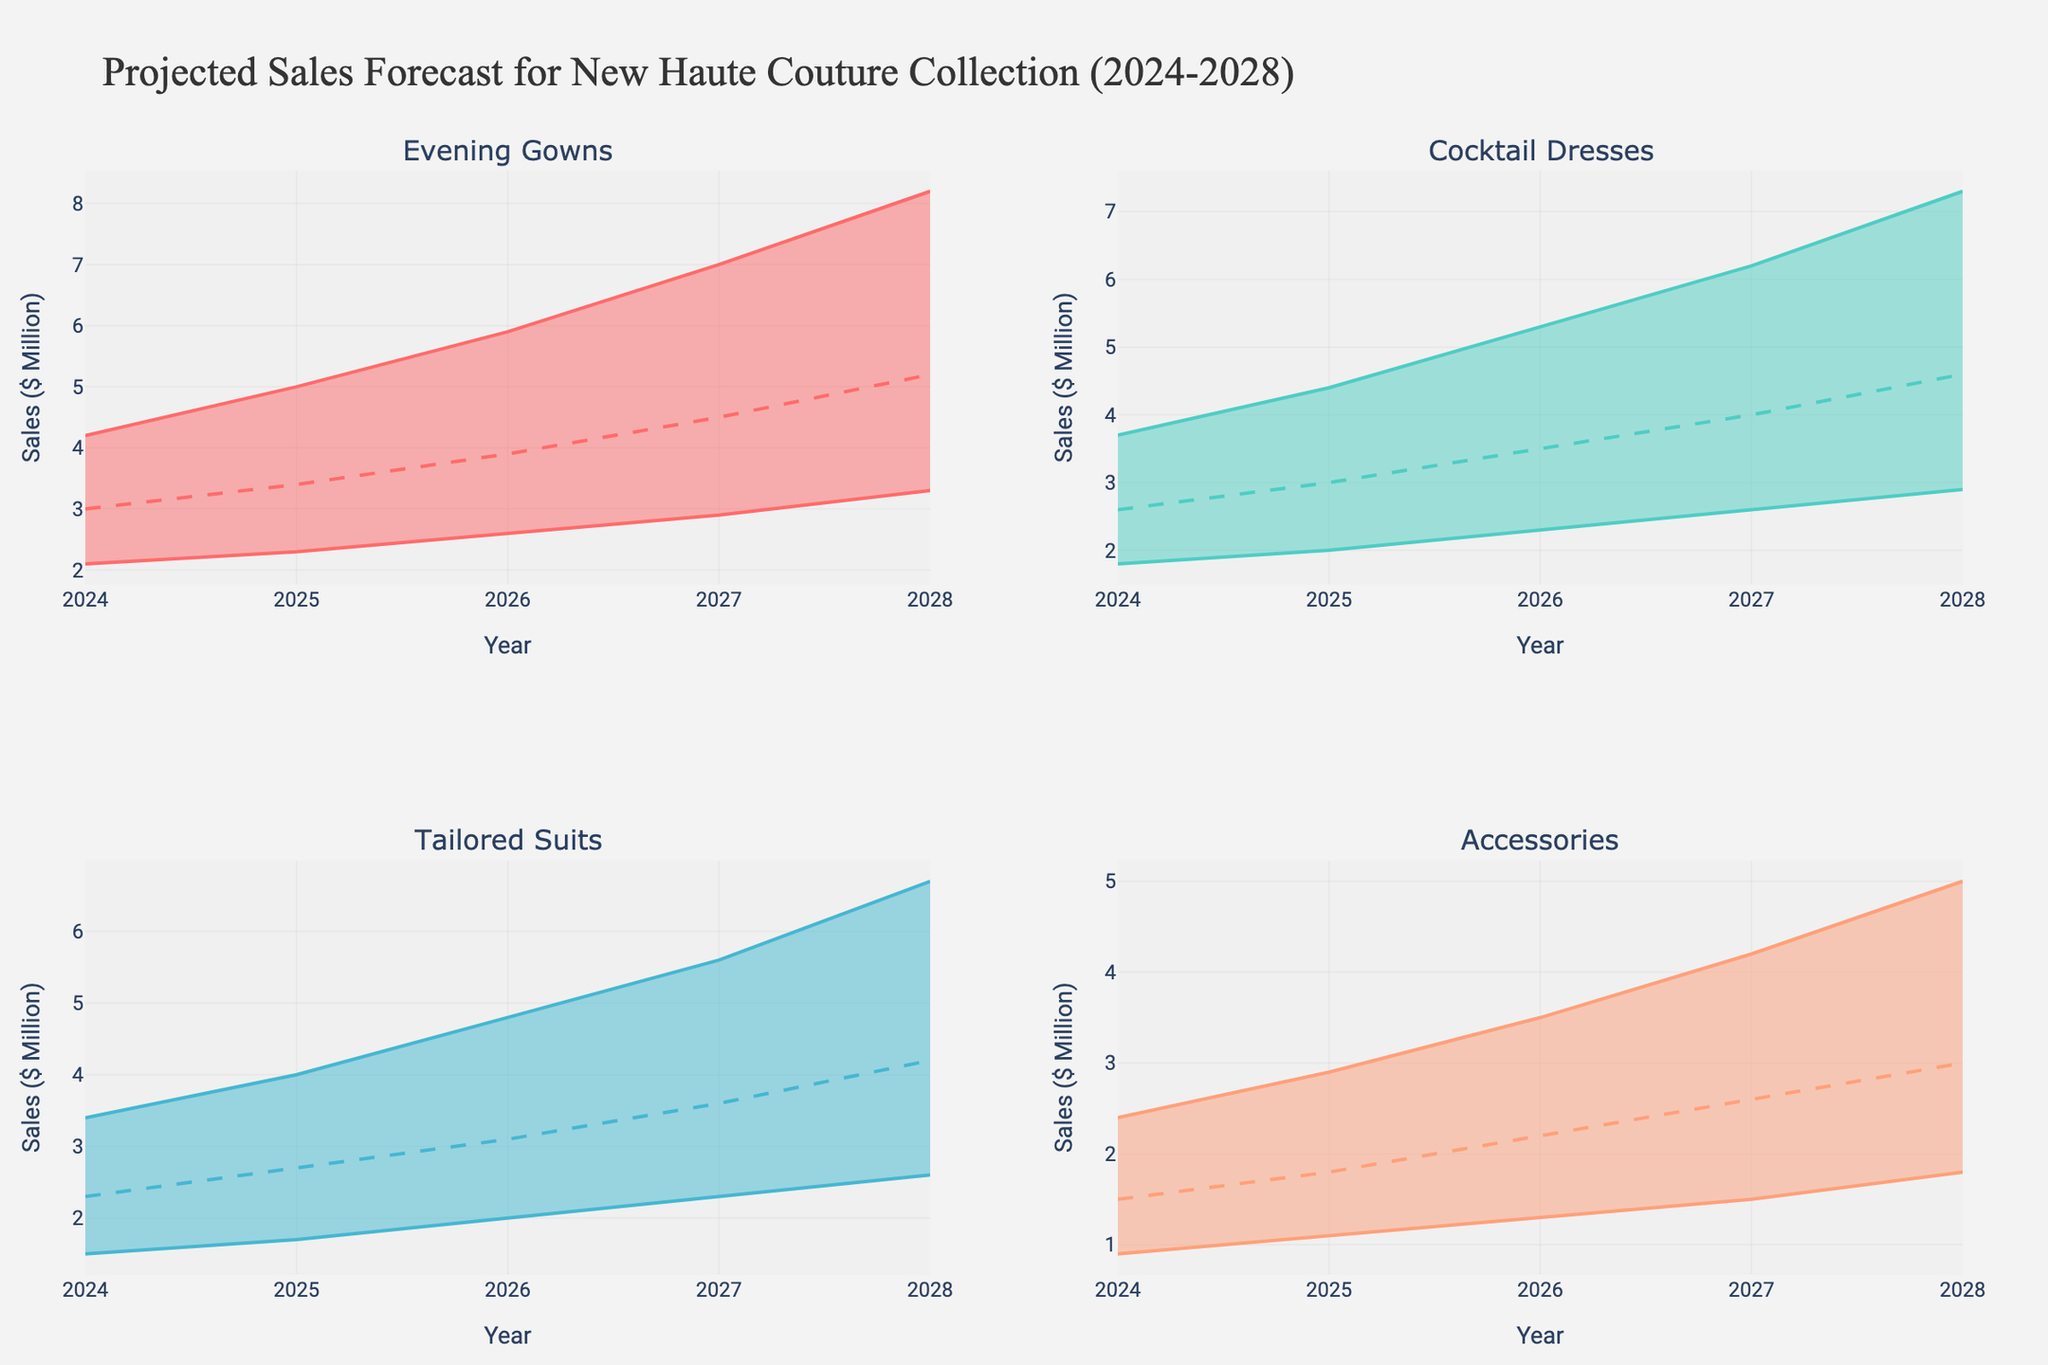What's the title of the figure? The title of the figure is typically located at the top of the plot. You can directly read it from there.
Answer: Projected Sales Forecast for New Haute Couture Collection (2024-2028) What product category has the highest sales forecast in 2028 according to the 'Mid' projection? To find the product category with the highest 'Mid' projection for 2028, you need to look at the midpoint values for all categories in 2028 and compare them.
Answer: Evening Gowns What is the forecasted sales range for 'Cocktail Dresses' in 2027? To determine the sales range for 'Cocktail Dresses' in 2027, you need to find the minimum (Low) and maximum (High) forecasted values from the 2027 data for Cocktail Dresses.
Answer: 2.6 to 6.2 million dollars By how much does the 'Mid' sales projection for 'Tailored Suits' increase from 2024 to 2028? To find the increase, subtract the 'Mid' projection in 2024 from the 'Mid' projection in 2028 for 'Tailored Suits'. The calculation is 4.2 - 2.3.
Answer: 1.9 million dollars Which product category shows the smallest variation between 'Low' and 'High' sales forecasts in 2024? To determine this, calculate the difference between the 'High' and 'Low' values for each category in 2024 and find the smallest difference.
Answer: Accessories Are Evening Gowns expected to have higher sales than Cocktail Dresses in 2026 based on the 'Mid' projections? Compare the 'Mid' projections for Evening Gowns (3.9) and Cocktail Dresses (3.5) in 2026. 3.9 is greater than 3.5, so yes.
Answer: Yes What is the average 'Mid' projection for 'Accessories' sales from 2024 to 2028? Add the 'Mid' projections for 'Accessories' from 2024 to 2028 and divide by the number of years (5). Calculation: (1.5 + 1.8 + 2.2 + 2.6 + 3.0)/5.
Answer: 2.22 million dollars Which year shows the highest 'Low' projection for 'Tailored Suits'? Compare the 'Low' projections for 'Tailored Suits' across all years and identify the highest value.
Answer: 2028 How does the sales forecast for 'Accessories' in 2028 compare to its forecast in 2024 considering the 'High' projections? Compare the 'High' projection for 'Accessories' in 2028 (5.0) to the 'High' projection in 2024 (2.4). 5.0 is greater than 2.4, so it's higher.
Answer: Higher If the 'Mid-High' projections are used, which product category is expected to have the largest absolute growth from 2025 to 2028? Calculate the difference in 'Mid-High' projections for each category between 2025 and 2028, then identify the category with the largest difference. Largest absolute growth: Evening Gowns (6.5 - 4.1 = 2.4 million dollars).
Answer: Evening Gowns 